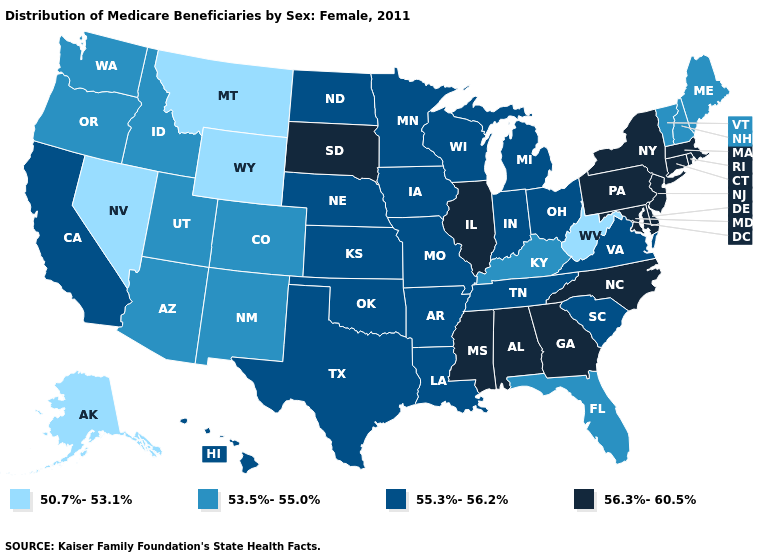What is the highest value in states that border Maryland?
Write a very short answer. 56.3%-60.5%. Which states hav the highest value in the South?
Be succinct. Alabama, Delaware, Georgia, Maryland, Mississippi, North Carolina. Which states hav the highest value in the Northeast?
Give a very brief answer. Connecticut, Massachusetts, New Jersey, New York, Pennsylvania, Rhode Island. What is the lowest value in the USA?
Short answer required. 50.7%-53.1%. Name the states that have a value in the range 56.3%-60.5%?
Write a very short answer. Alabama, Connecticut, Delaware, Georgia, Illinois, Maryland, Massachusetts, Mississippi, New Jersey, New York, North Carolina, Pennsylvania, Rhode Island, South Dakota. Name the states that have a value in the range 56.3%-60.5%?
Be succinct. Alabama, Connecticut, Delaware, Georgia, Illinois, Maryland, Massachusetts, Mississippi, New Jersey, New York, North Carolina, Pennsylvania, Rhode Island, South Dakota. What is the highest value in the MidWest ?
Keep it brief. 56.3%-60.5%. What is the highest value in states that border Massachusetts?
Quick response, please. 56.3%-60.5%. What is the lowest value in states that border New Mexico?
Short answer required. 53.5%-55.0%. What is the value of Colorado?
Keep it brief. 53.5%-55.0%. What is the value of Massachusetts?
Quick response, please. 56.3%-60.5%. Does South Carolina have a lower value than Nevada?
Concise answer only. No. Does New Mexico have a higher value than Tennessee?
Keep it brief. No. Which states hav the highest value in the Northeast?
Give a very brief answer. Connecticut, Massachusetts, New Jersey, New York, Pennsylvania, Rhode Island. How many symbols are there in the legend?
Keep it brief. 4. 